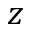Convert formula to latex. <formula><loc_0><loc_0><loc_500><loc_500>z</formula> 